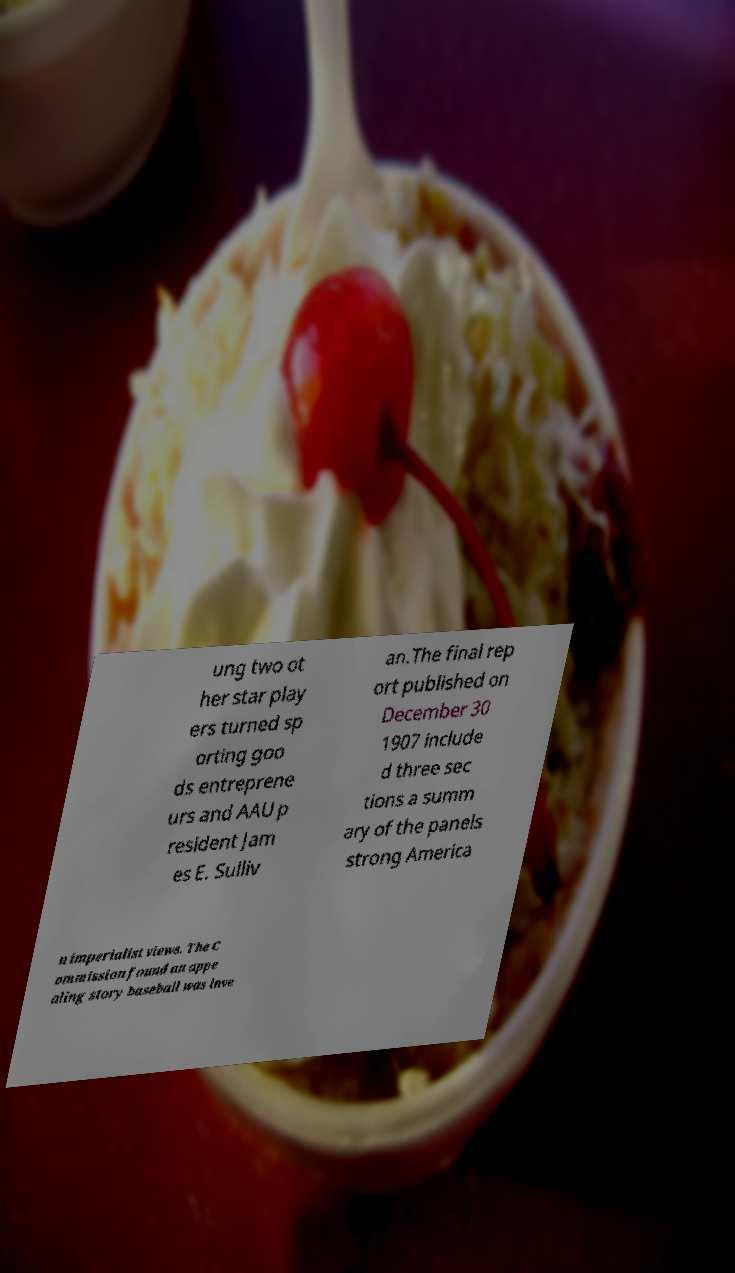Could you assist in decoding the text presented in this image and type it out clearly? ung two ot her star play ers turned sp orting goo ds entreprene urs and AAU p resident Jam es E. Sulliv an.The final rep ort published on December 30 1907 include d three sec tions a summ ary of the panels strong America n imperialist views. The C ommission found an appe aling story baseball was inve 